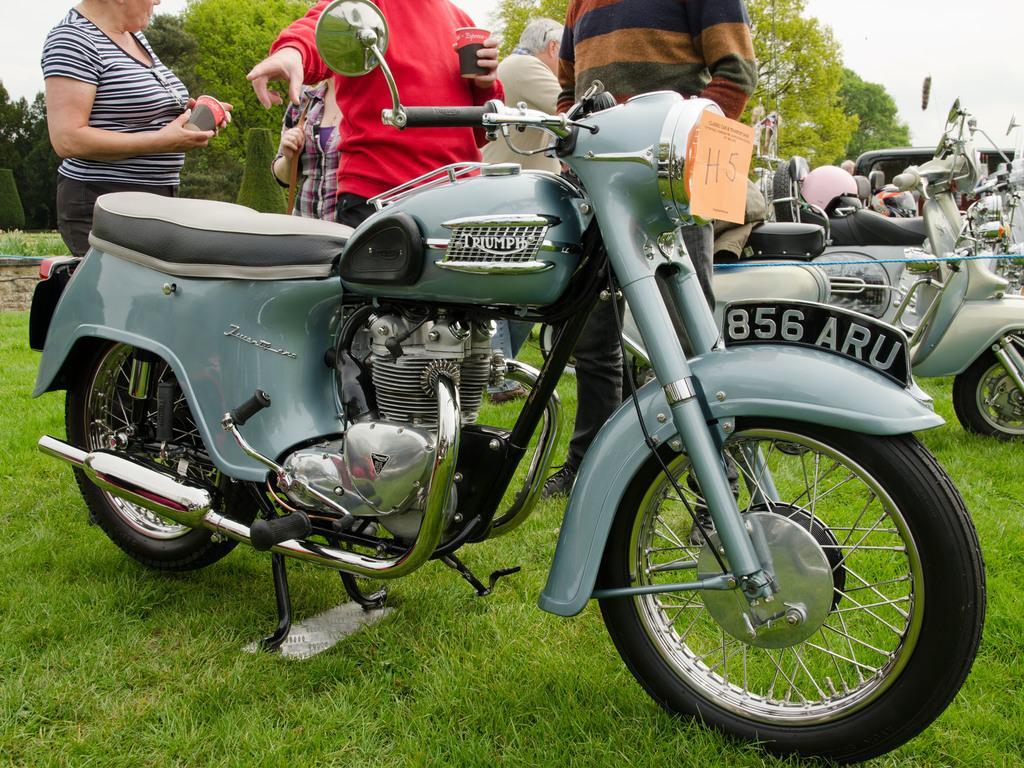How would you summarize this image in a sentence or two? In this image we can see some group of vehicles parked, there are some group of persons and in the background of the image there are some trees and clear sky. 